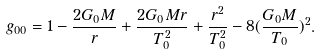<formula> <loc_0><loc_0><loc_500><loc_500>g _ { 0 0 } = 1 - \frac { 2 G _ { 0 } M } { r } + \frac { 2 G _ { 0 } M r } { T _ { 0 } ^ { 2 } } + \frac { r ^ { 2 } } { T _ { 0 } ^ { 2 } } - 8 ( \frac { G _ { 0 } M } { T _ { 0 } } ) ^ { 2 } .</formula> 